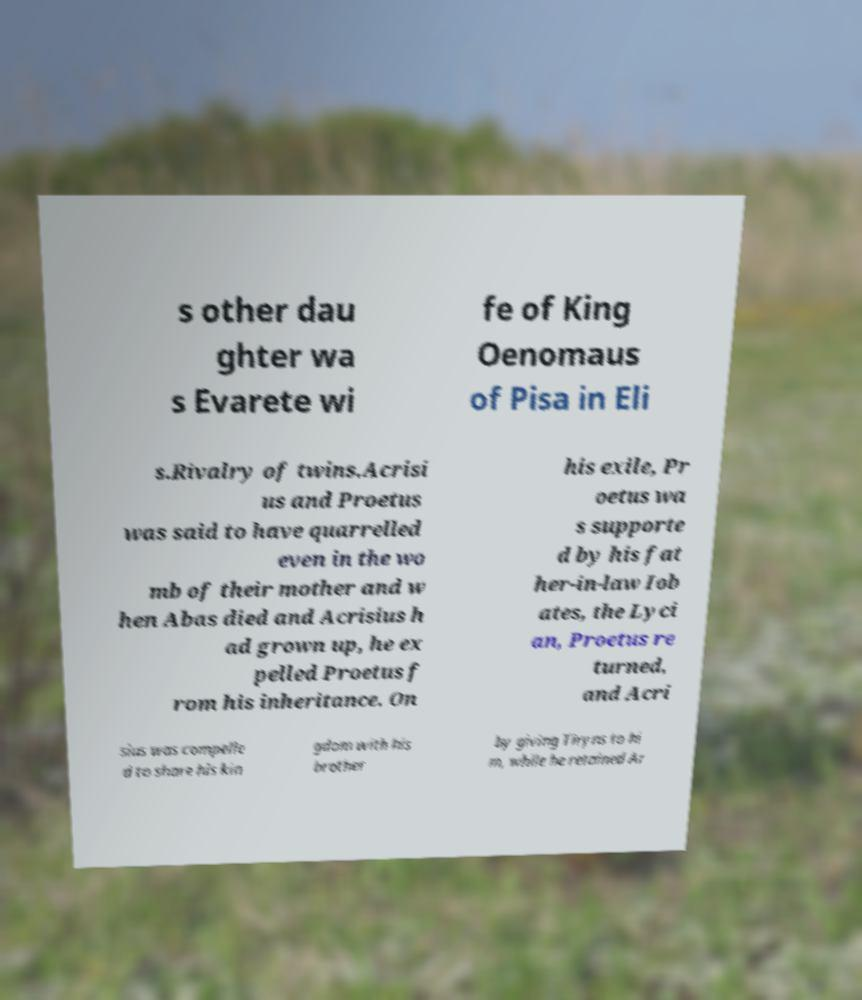Can you read and provide the text displayed in the image?This photo seems to have some interesting text. Can you extract and type it out for me? s other dau ghter wa s Evarete wi fe of King Oenomaus of Pisa in Eli s.Rivalry of twins.Acrisi us and Proetus was said to have quarrelled even in the wo mb of their mother and w hen Abas died and Acrisius h ad grown up, he ex pelled Proetus f rom his inheritance. On his exile, Pr oetus wa s supporte d by his fat her-in-law Iob ates, the Lyci an, Proetus re turned, and Acri sius was compelle d to share his kin gdom with his brother by giving Tiryns to hi m, while he retained Ar 